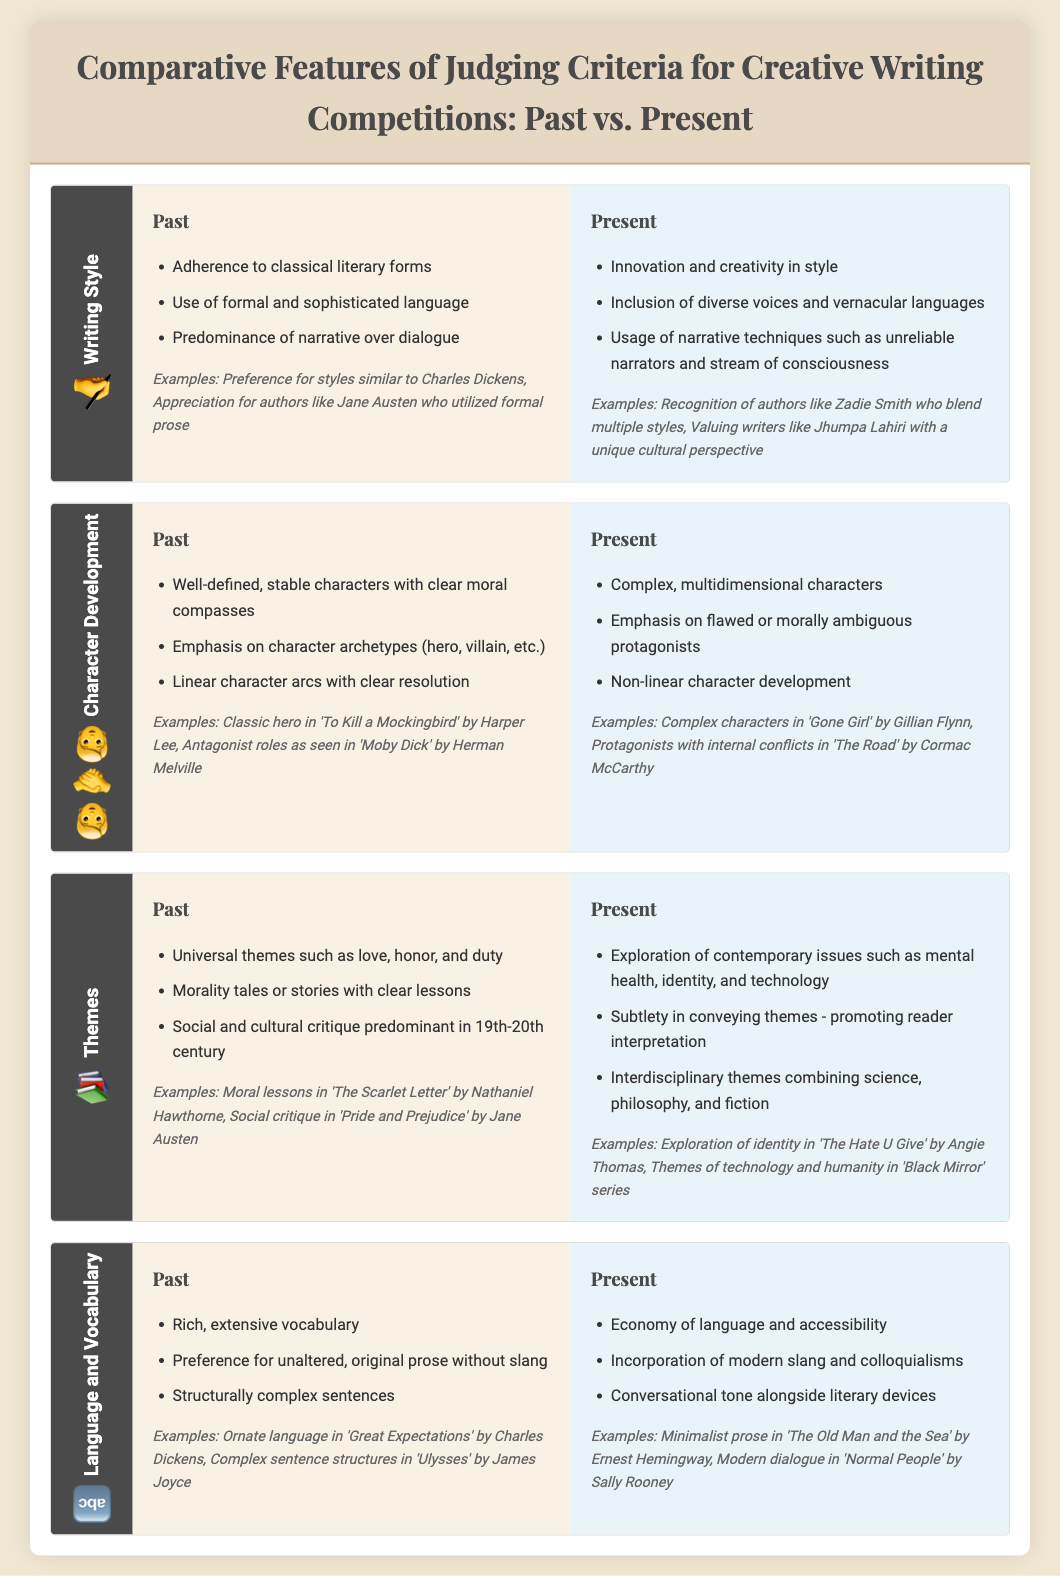What are the three past judging criteria aspects for Writing Style? The three past aspects listed are Adherence to classical literary forms, Use of formal and sophisticated language, and Predominance of narrative over dialogue.
Answer: Adherence to classical literary forms, Use of formal and sophisticated language, Predominance of narrative over dialogue What examples represent past Writing Style? Examples given include styles similar to Charles Dickens and appreciation for authors like Jane Austen who utilized formal prose.
Answer: Charles Dickens, Jane Austen What are the three present judging criteria aspects for Character Development? The three present aspects listed are Complex, multidimensional characters, Emphasis on flawed or morally ambiguous protagonists, and Non-linear character development.
Answer: Complex, multidimensional characters, Emphasis on flawed or morally ambiguous protagonists, Non-linear character development Which author signifies the exploration of contemporary issues in Themes? The example given for contemporary issues in Themes is 'The Hate U Give' by Angie Thomas, which explores identity.
Answer: Angie Thomas What is a difference in Language and Vocabulary between past and present? The past emphasized rich, extensive vocabulary, while the present focuses on an economy of language and accessibility.
Answer: Rich, extensive vocabulary vs. economy of language and accessibility What kind of characters are emphasized in past Character Development? The past emphasizes well-defined, stable characters with clear moral compasses.
Answer: Well-defined, stable characters What is a notable theme from the past? The past featured universal themes such as love, honor, and duty.
Answer: Universal themes such as love, honor, and duty What distinguishes language usage in present writing? Present writing incorporates modern slang and colloquialisms alongside a conversational tone.
Answer: Incorporation of modern slang and colloquialisms 